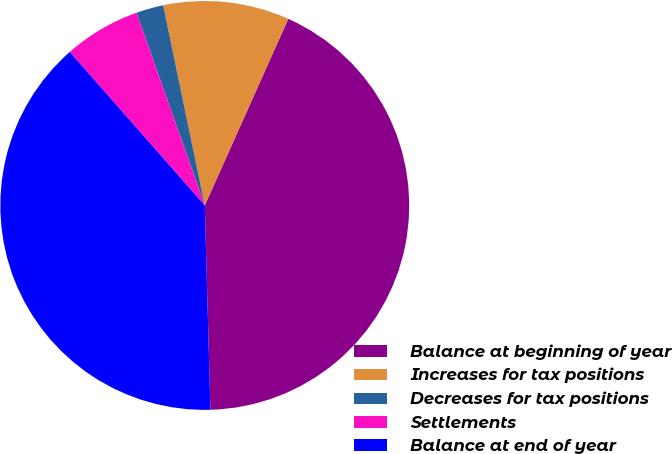Convert chart to OTSL. <chart><loc_0><loc_0><loc_500><loc_500><pie_chart><fcel>Balance at beginning of year<fcel>Increases for tax positions<fcel>Decreases for tax positions<fcel>Settlements<fcel>Balance at end of year<nl><fcel>42.86%<fcel>9.96%<fcel>2.16%<fcel>6.06%<fcel>38.96%<nl></chart> 